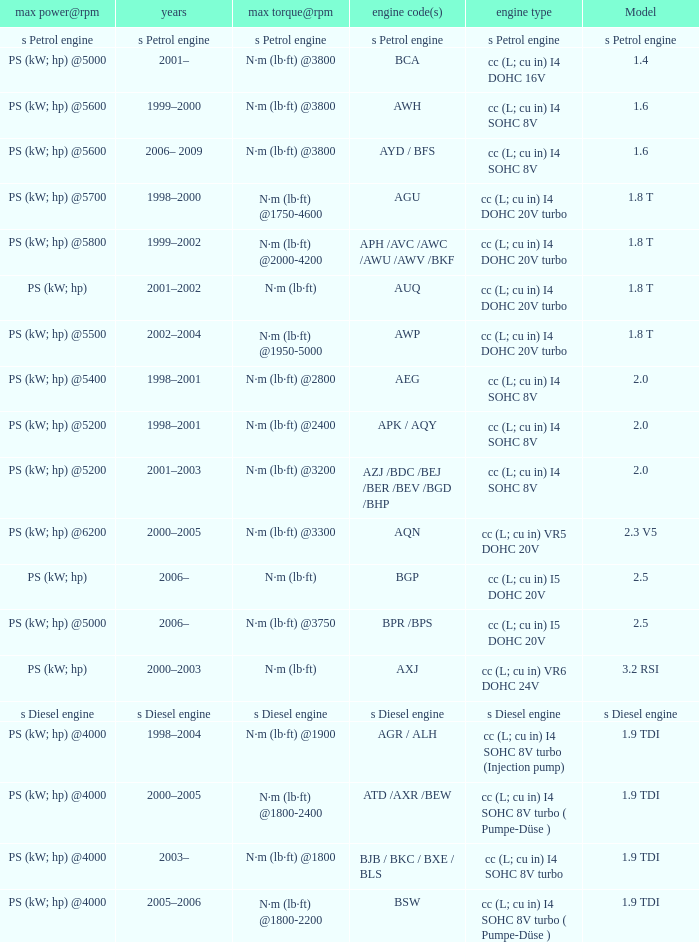What was the max torque@rpm of the engine which had the model 2.5  and a max power@rpm of ps (kw; hp) @5000? N·m (lb·ft) @3750. 